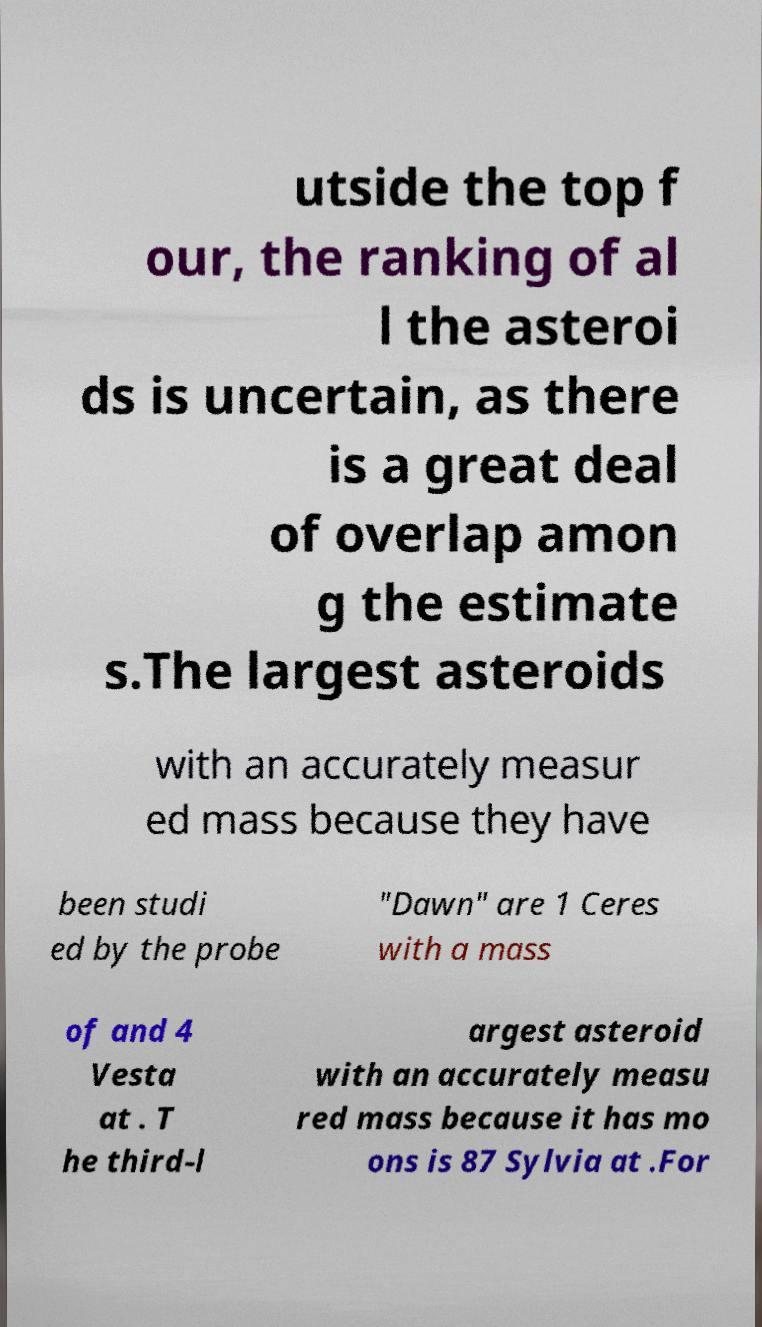Could you assist in decoding the text presented in this image and type it out clearly? utside the top f our, the ranking of al l the asteroi ds is uncertain, as there is a great deal of overlap amon g the estimate s.The largest asteroids with an accurately measur ed mass because they have been studi ed by the probe "Dawn" are 1 Ceres with a mass of and 4 Vesta at . T he third-l argest asteroid with an accurately measu red mass because it has mo ons is 87 Sylvia at .For 